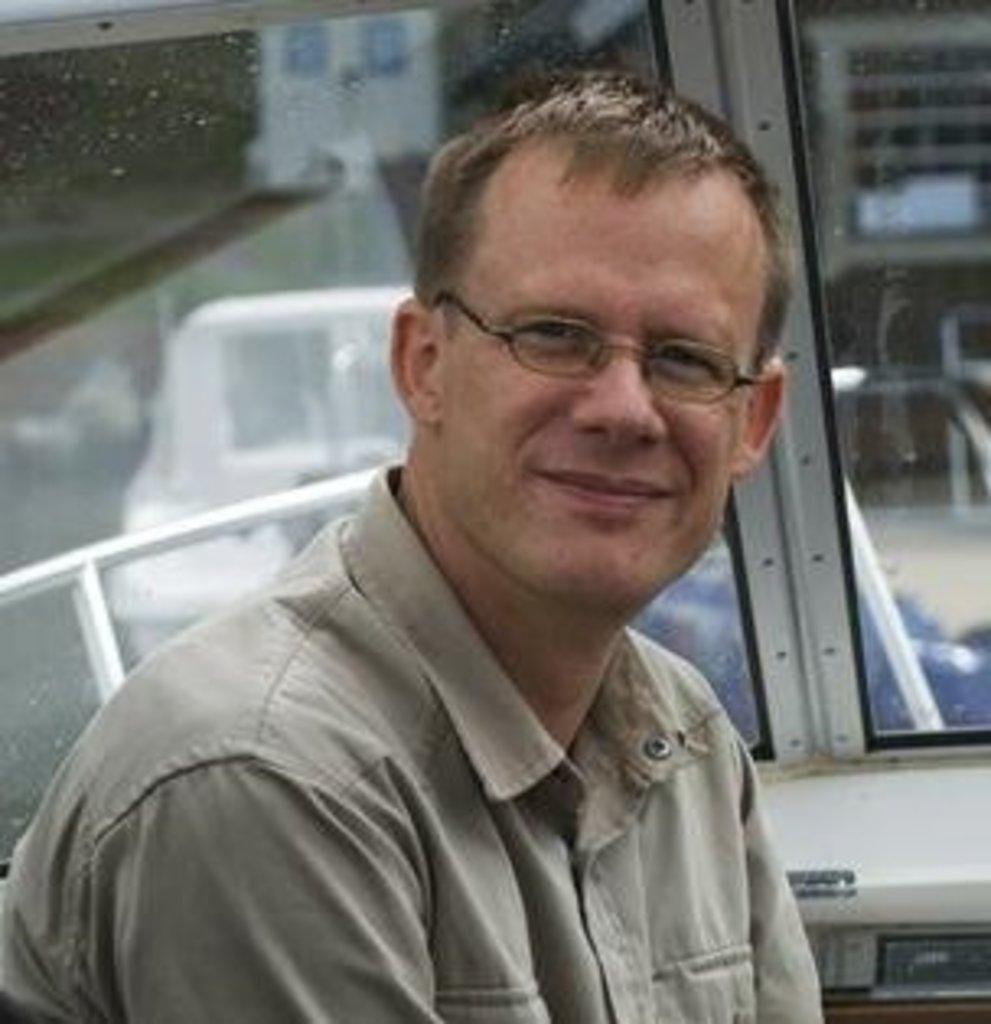What is the person in the image wearing? The person is wearing spectacles in the image. Can you describe the setting of the person in the image? The person might be in a vehicle, as suggested by the presence of a window. What can be seen through the window in the image? The wall and other objects are visible through the window in the image. What type of lead is being used to expand the boundary in the image? There is no mention of lead, expansion, or boundaries in the image. The image primarily features a person wearing spectacles in a vehicle with a visible window. 